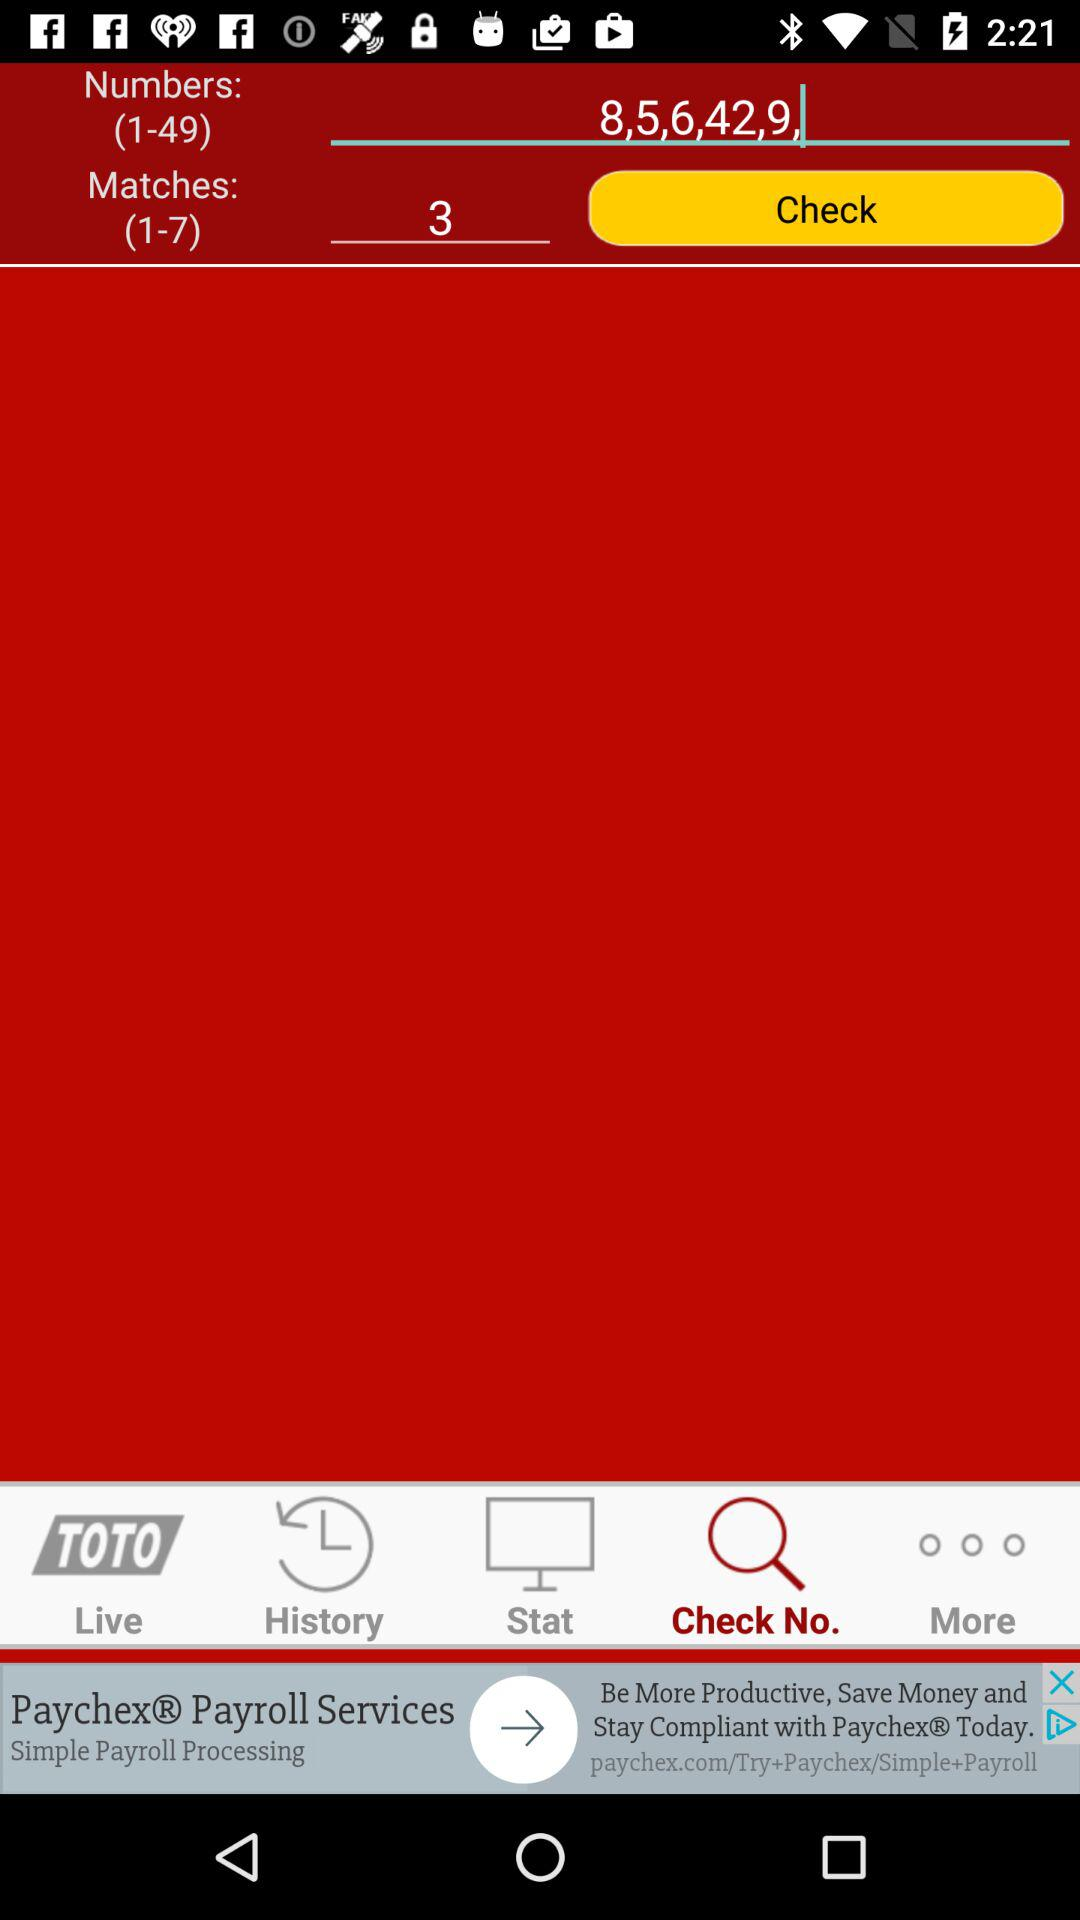Which tab is selected? The selected tab is "Check No.". 